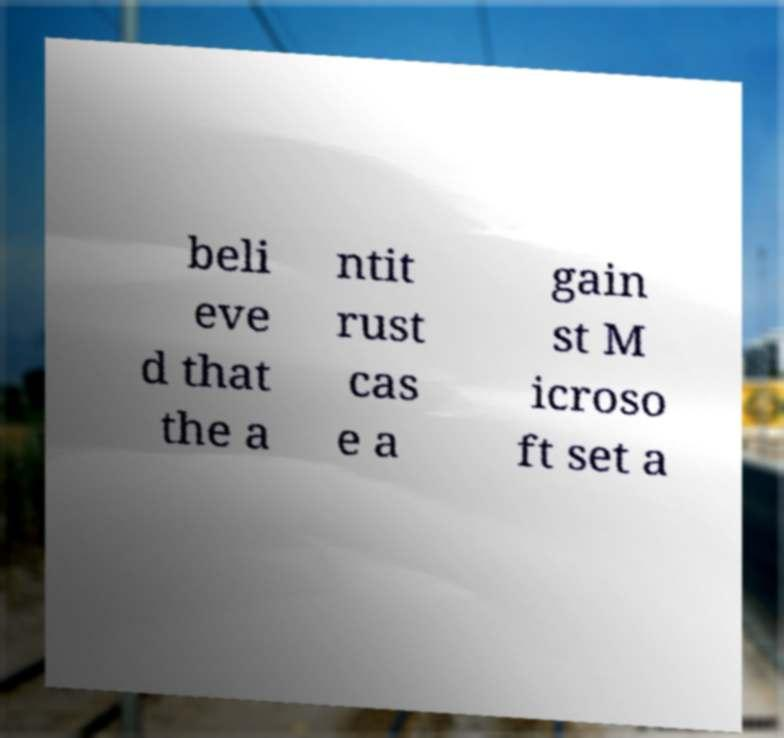Could you extract and type out the text from this image? beli eve d that the a ntit rust cas e a gain st M icroso ft set a 